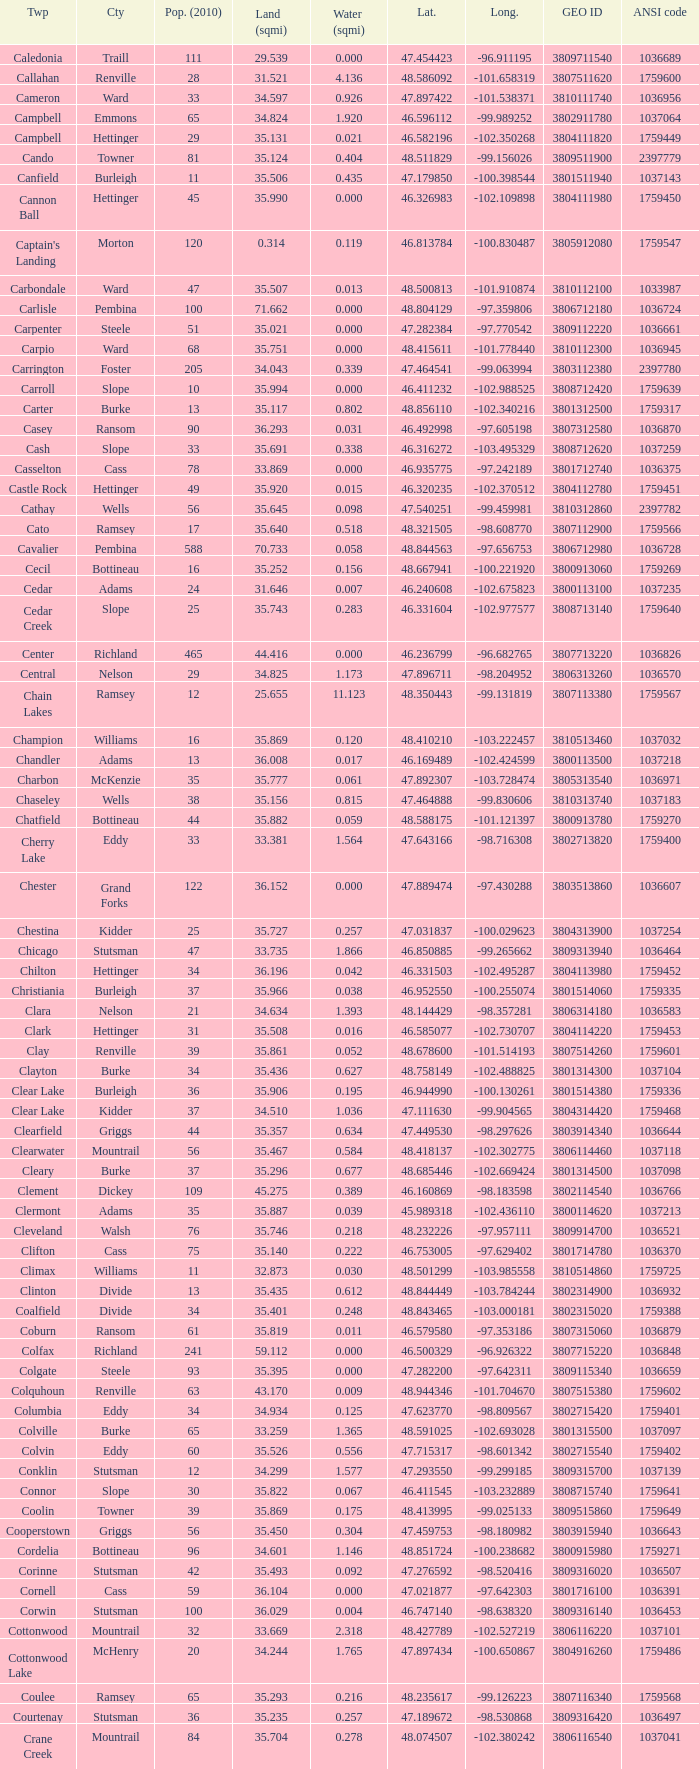What was the county with a latitude of 46.770977? Kidder. 